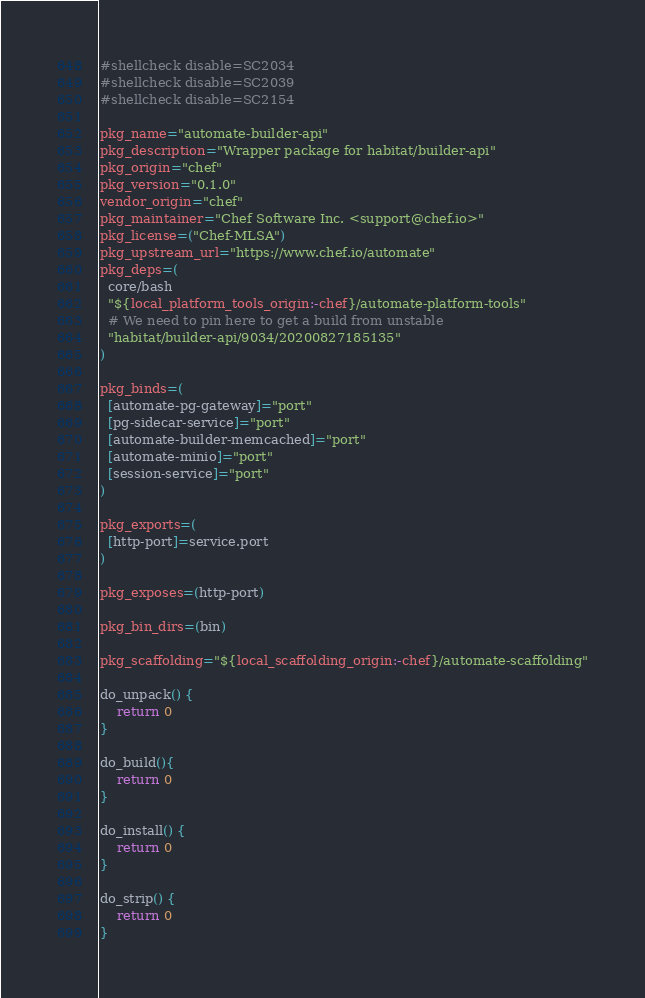<code> <loc_0><loc_0><loc_500><loc_500><_Bash_>#shellcheck disable=SC2034
#shellcheck disable=SC2039
#shellcheck disable=SC2154

pkg_name="automate-builder-api"
pkg_description="Wrapper package for habitat/builder-api"
pkg_origin="chef"
pkg_version="0.1.0"
vendor_origin="chef"
pkg_maintainer="Chef Software Inc. <support@chef.io>"
pkg_license=("Chef-MLSA")
pkg_upstream_url="https://www.chef.io/automate"
pkg_deps=(
  core/bash
  "${local_platform_tools_origin:-chef}/automate-platform-tools"
  # We need to pin here to get a build from unstable
  "habitat/builder-api/9034/20200827185135"
)

pkg_binds=(
  [automate-pg-gateway]="port"
  [pg-sidecar-service]="port"
  [automate-builder-memcached]="port"
  [automate-minio]="port"
  [session-service]="port"
)

pkg_exports=(
  [http-port]=service.port
)

pkg_exposes=(http-port)

pkg_bin_dirs=(bin)

pkg_scaffolding="${local_scaffolding_origin:-chef}/automate-scaffolding"

do_unpack() {
    return 0
}

do_build(){
    return 0
}

do_install() {
    return 0
}

do_strip() {
    return 0
}
</code> 